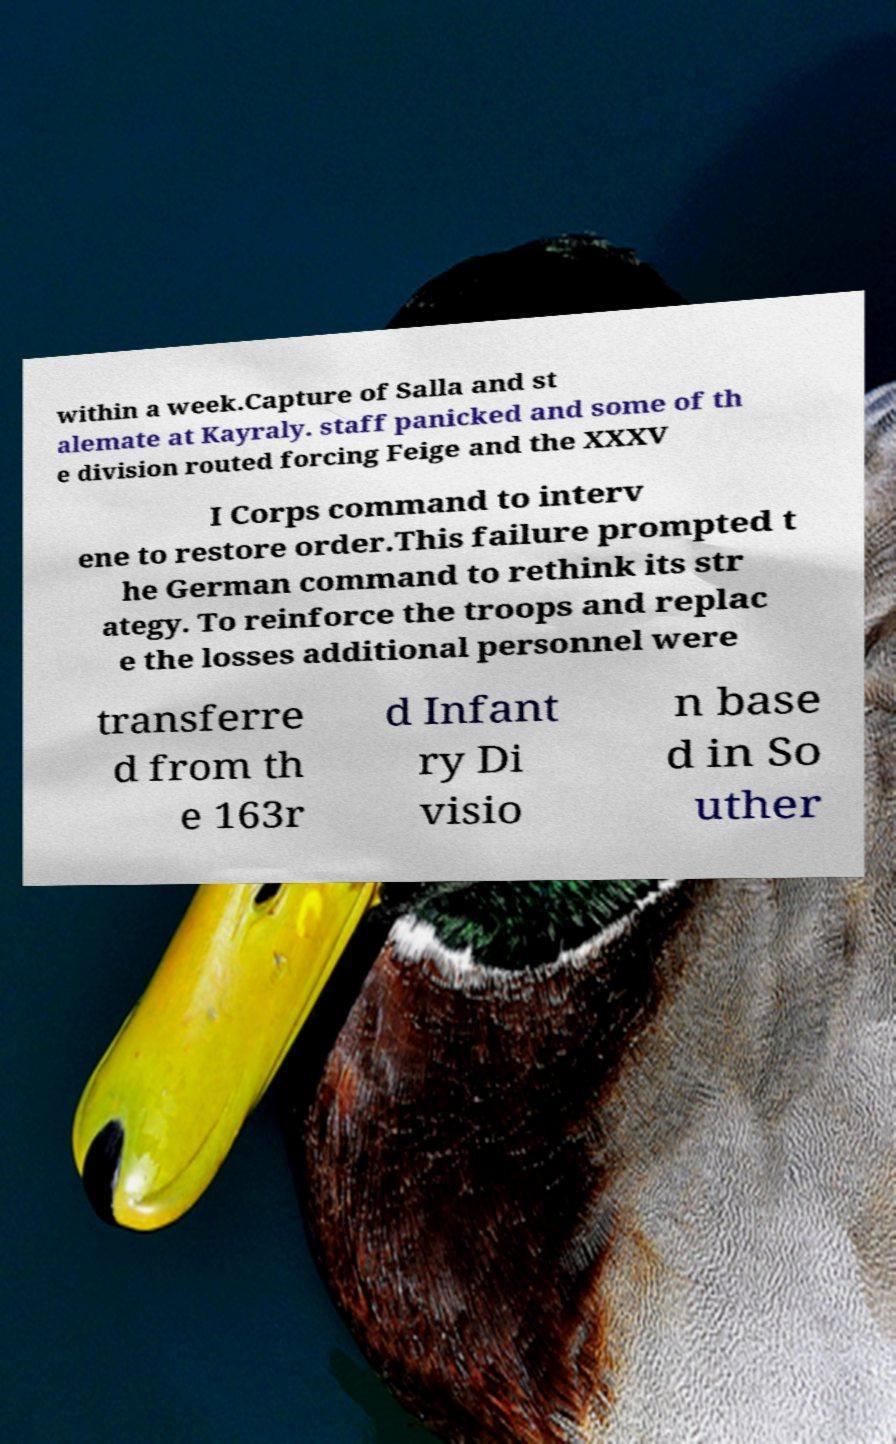What messages or text are displayed in this image? I need them in a readable, typed format. within a week.Capture of Salla and st alemate at Kayraly. staff panicked and some of th e division routed forcing Feige and the XXXV I Corps command to interv ene to restore order.This failure prompted t he German command to rethink its str ategy. To reinforce the troops and replac e the losses additional personnel were transferre d from th e 163r d Infant ry Di visio n base d in So uther 